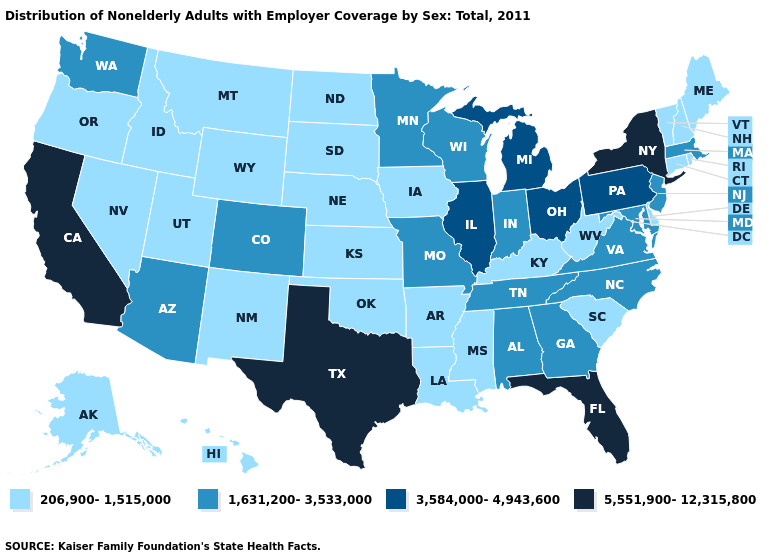Name the states that have a value in the range 206,900-1,515,000?
Give a very brief answer. Alaska, Arkansas, Connecticut, Delaware, Hawaii, Idaho, Iowa, Kansas, Kentucky, Louisiana, Maine, Mississippi, Montana, Nebraska, Nevada, New Hampshire, New Mexico, North Dakota, Oklahoma, Oregon, Rhode Island, South Carolina, South Dakota, Utah, Vermont, West Virginia, Wyoming. Which states hav the highest value in the West?
Quick response, please. California. Does Idaho have the highest value in the West?
Write a very short answer. No. Name the states that have a value in the range 5,551,900-12,315,800?
Quick response, please. California, Florida, New York, Texas. Name the states that have a value in the range 5,551,900-12,315,800?
Answer briefly. California, Florida, New York, Texas. Among the states that border New York , which have the highest value?
Quick response, please. Pennsylvania. How many symbols are there in the legend?
Concise answer only. 4. Among the states that border Louisiana , does Texas have the lowest value?
Write a very short answer. No. What is the highest value in the USA?
Be succinct. 5,551,900-12,315,800. Does the first symbol in the legend represent the smallest category?
Be succinct. Yes. Does the map have missing data?
Be succinct. No. Name the states that have a value in the range 5,551,900-12,315,800?
Concise answer only. California, Florida, New York, Texas. Does the map have missing data?
Give a very brief answer. No. Name the states that have a value in the range 1,631,200-3,533,000?
Quick response, please. Alabama, Arizona, Colorado, Georgia, Indiana, Maryland, Massachusetts, Minnesota, Missouri, New Jersey, North Carolina, Tennessee, Virginia, Washington, Wisconsin. Name the states that have a value in the range 206,900-1,515,000?
Quick response, please. Alaska, Arkansas, Connecticut, Delaware, Hawaii, Idaho, Iowa, Kansas, Kentucky, Louisiana, Maine, Mississippi, Montana, Nebraska, Nevada, New Hampshire, New Mexico, North Dakota, Oklahoma, Oregon, Rhode Island, South Carolina, South Dakota, Utah, Vermont, West Virginia, Wyoming. 